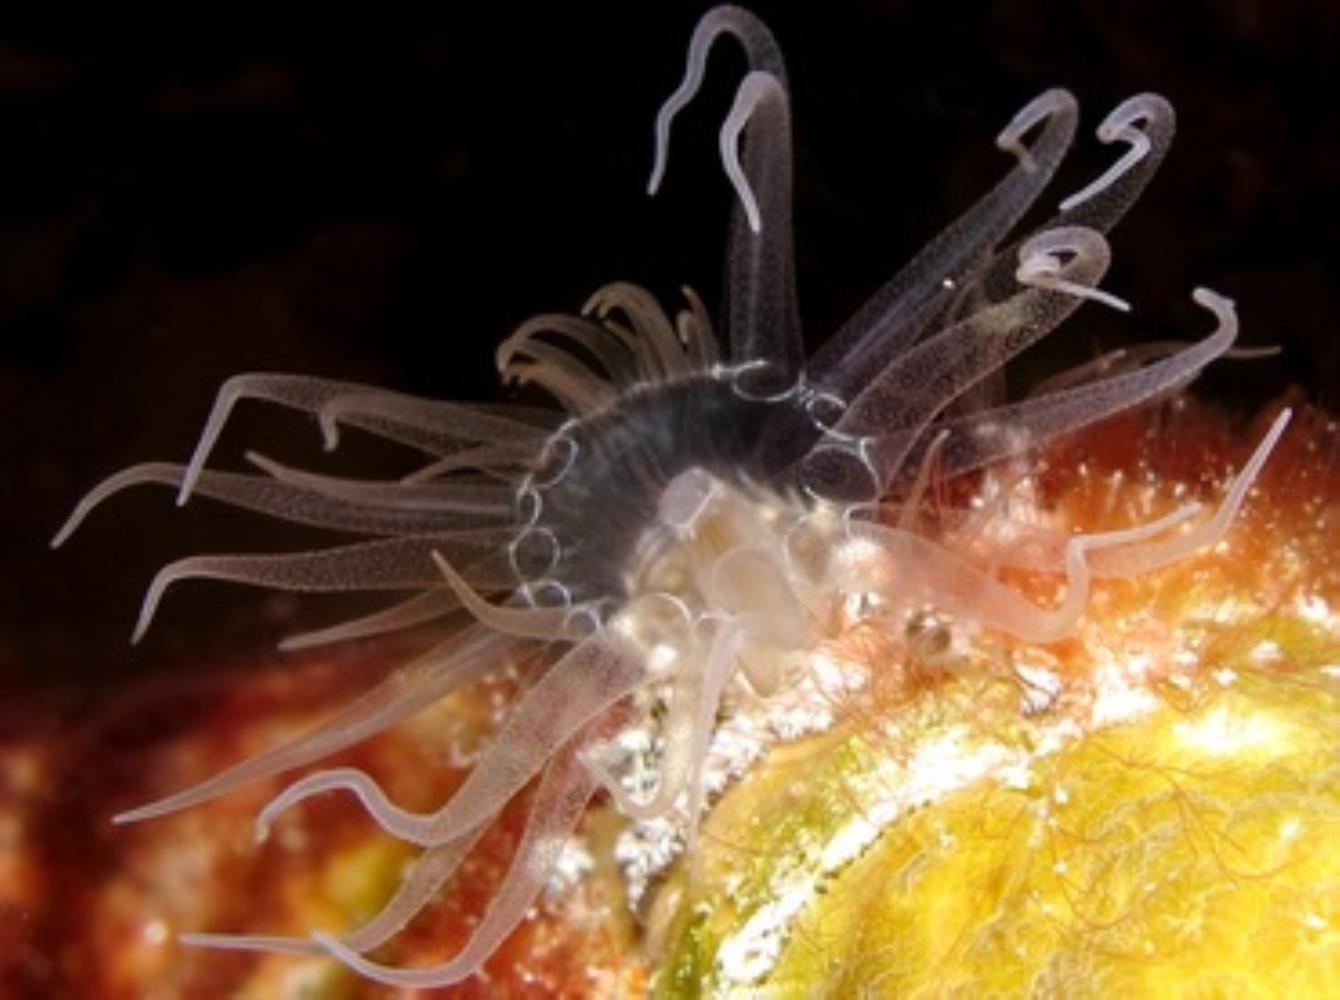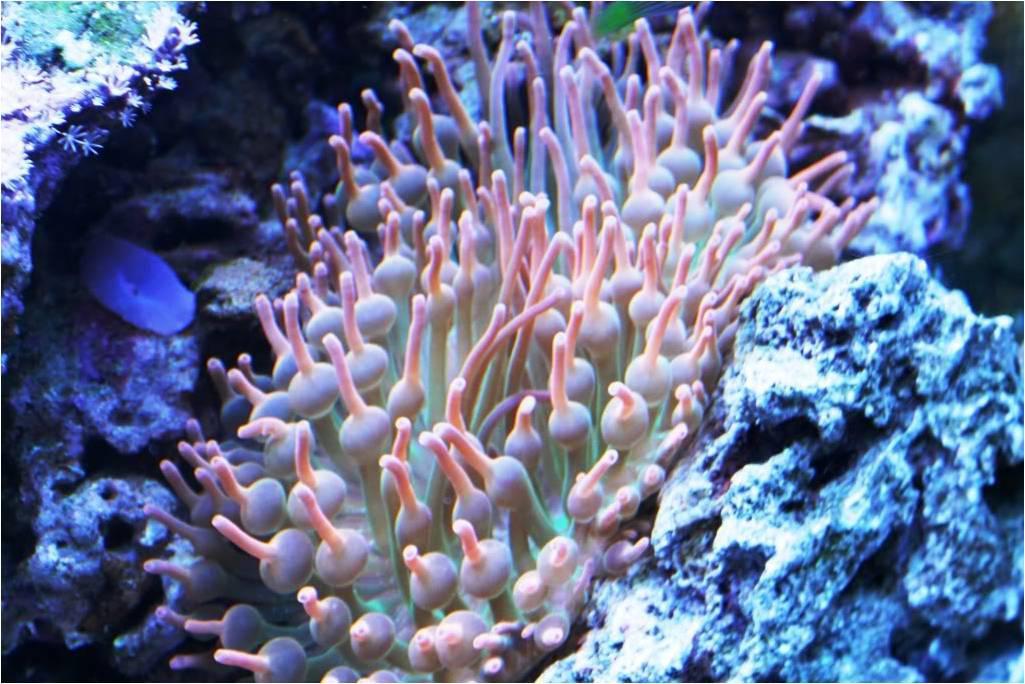The first image is the image on the left, the second image is the image on the right. Analyze the images presented: Is the assertion "In at least one image there is a fish tank holding at least one fish." valid? Answer yes or no. No. The first image is the image on the left, the second image is the image on the right. For the images shown, is this caption "Fish and coral are shown." true? Answer yes or no. No. 